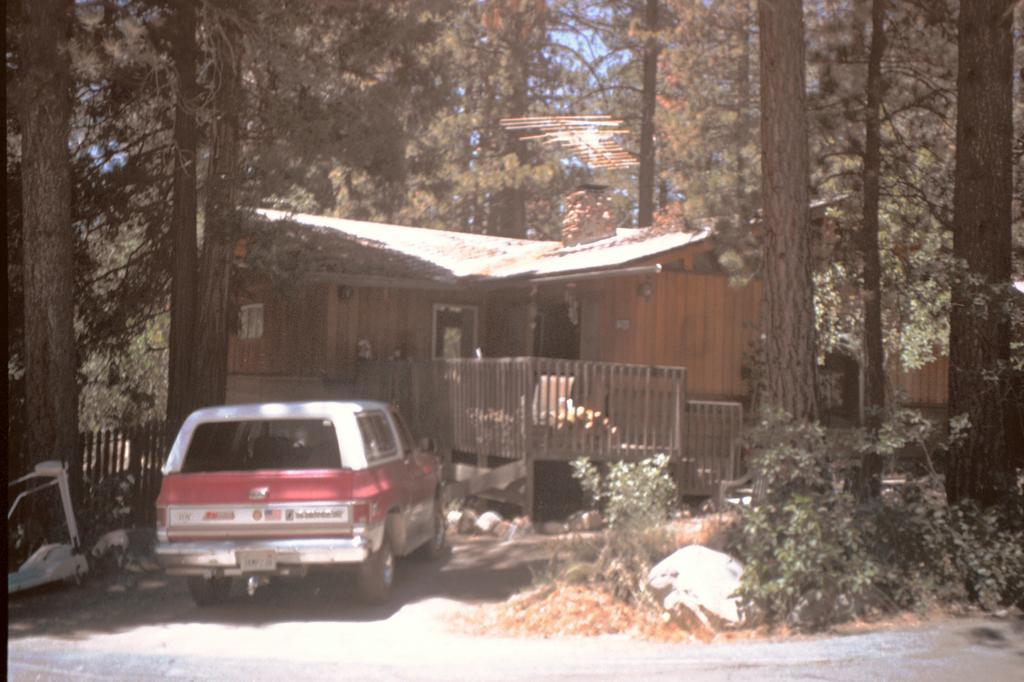In one or two sentences, can you explain what this image depicts? In the center of the image we can see house and car on the road. On the right side of the image we can see trees and plants. On the left side of the image we can see fencing and trees. In the background there is sky. 